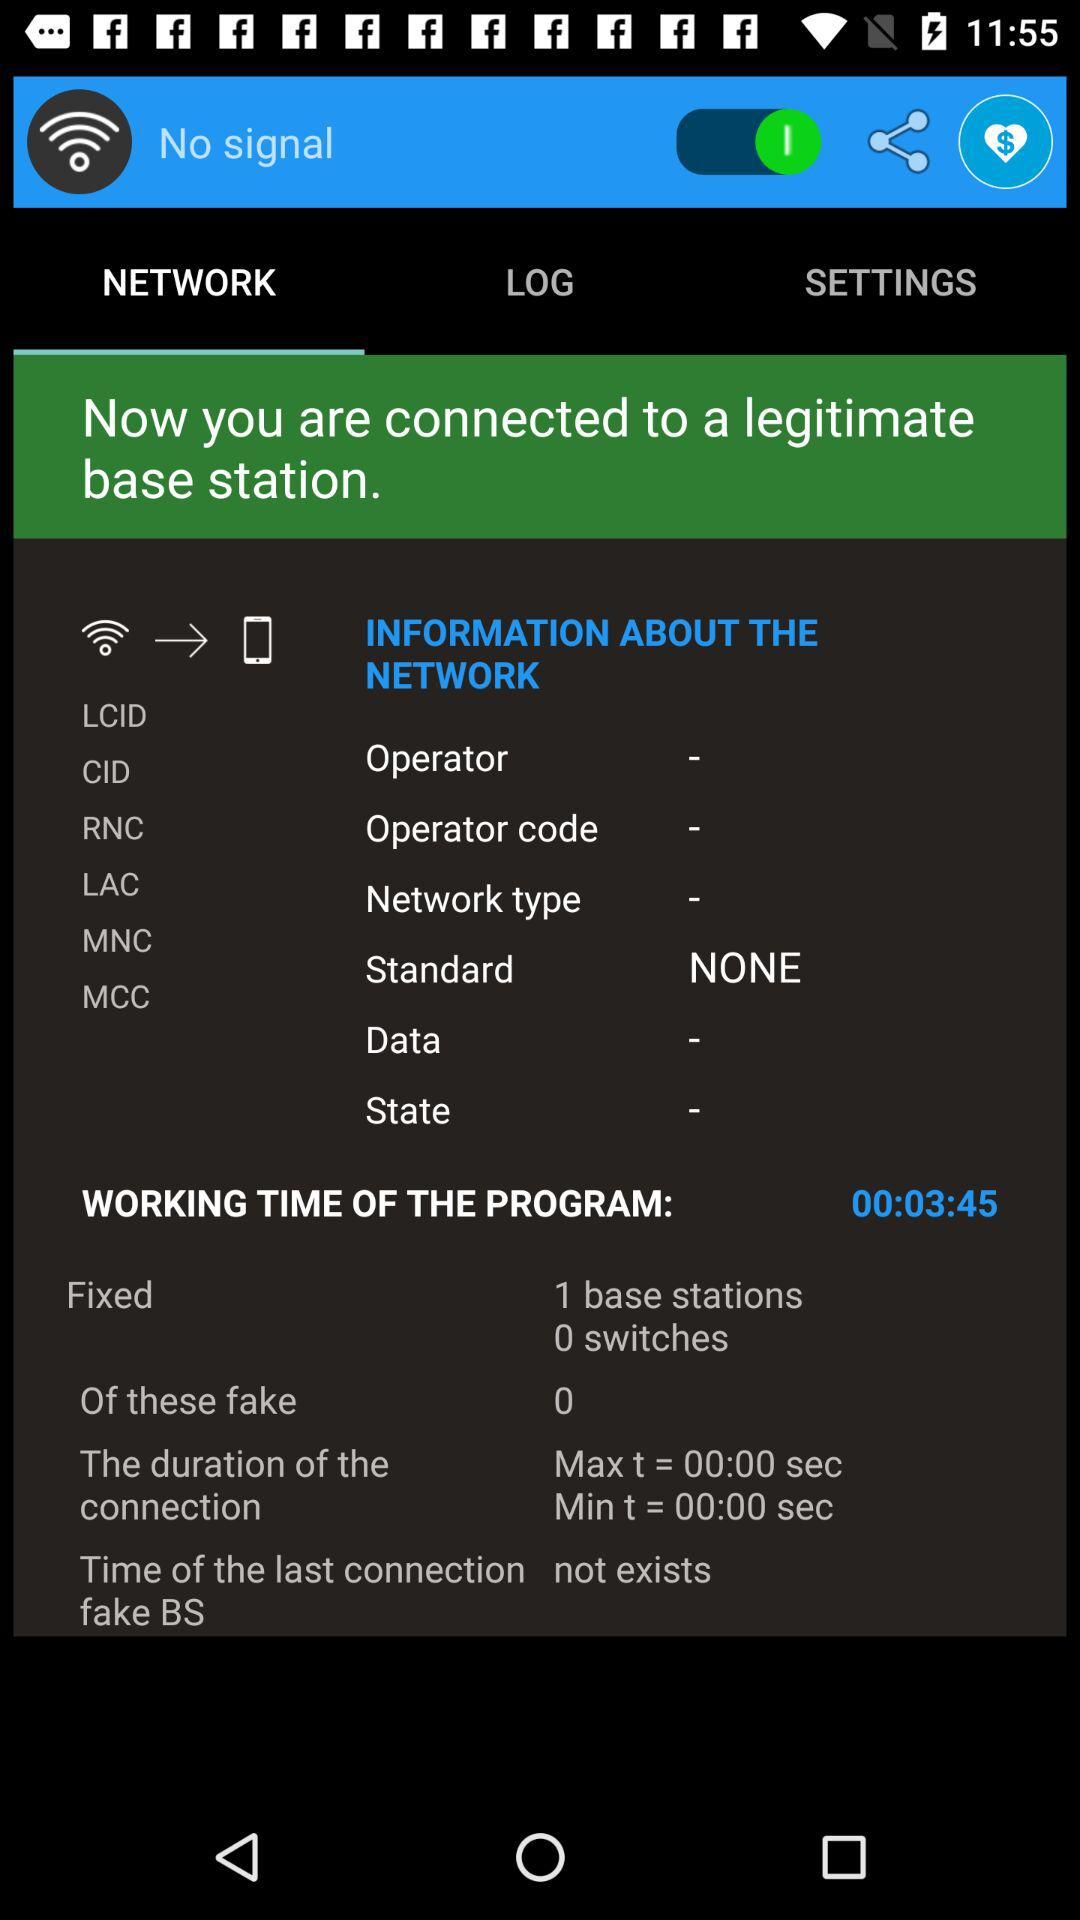On which tab am I now? You are on the "NETWORK" tab. 